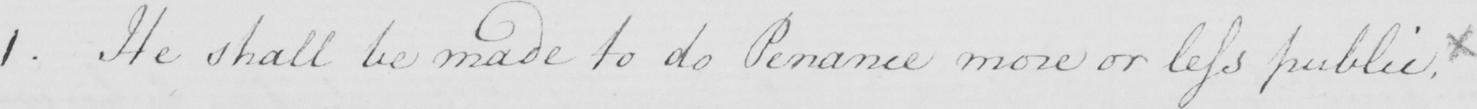Transcribe the text shown in this historical manuscript line. 1 . He shall be made to do Penance more or less public.x 